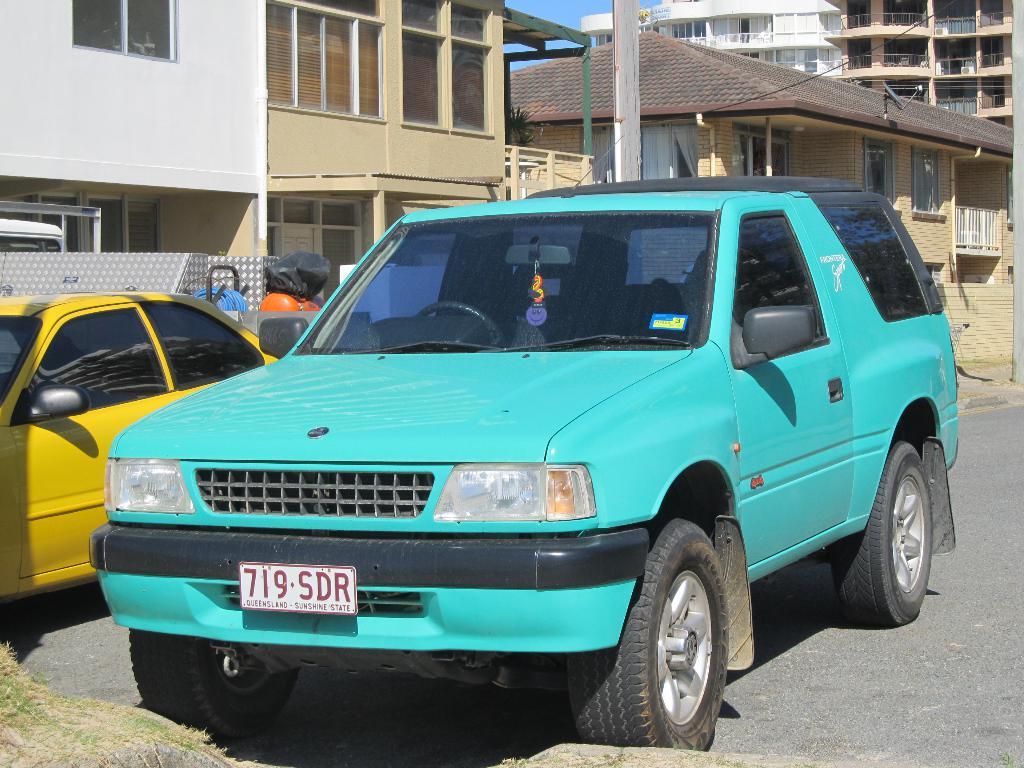What is the licence plate number of the turquoise car?
Offer a very short reply. 719 sdr. What is the sunshine state?
Your response must be concise. Queensland. 